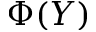<formula> <loc_0><loc_0><loc_500><loc_500>\Phi ( Y )</formula> 